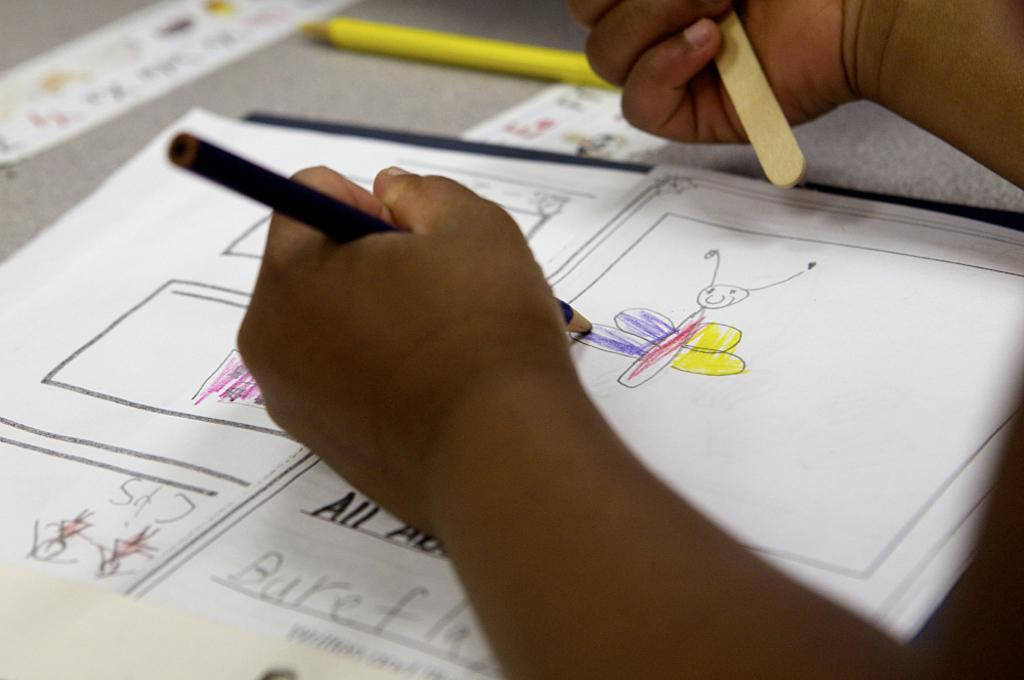<image>
Share a concise interpretation of the image provided. An African American child is drawing a picture of a butterfly on a sheet of paper that appears to say All about butterfly's spelled wrong. 